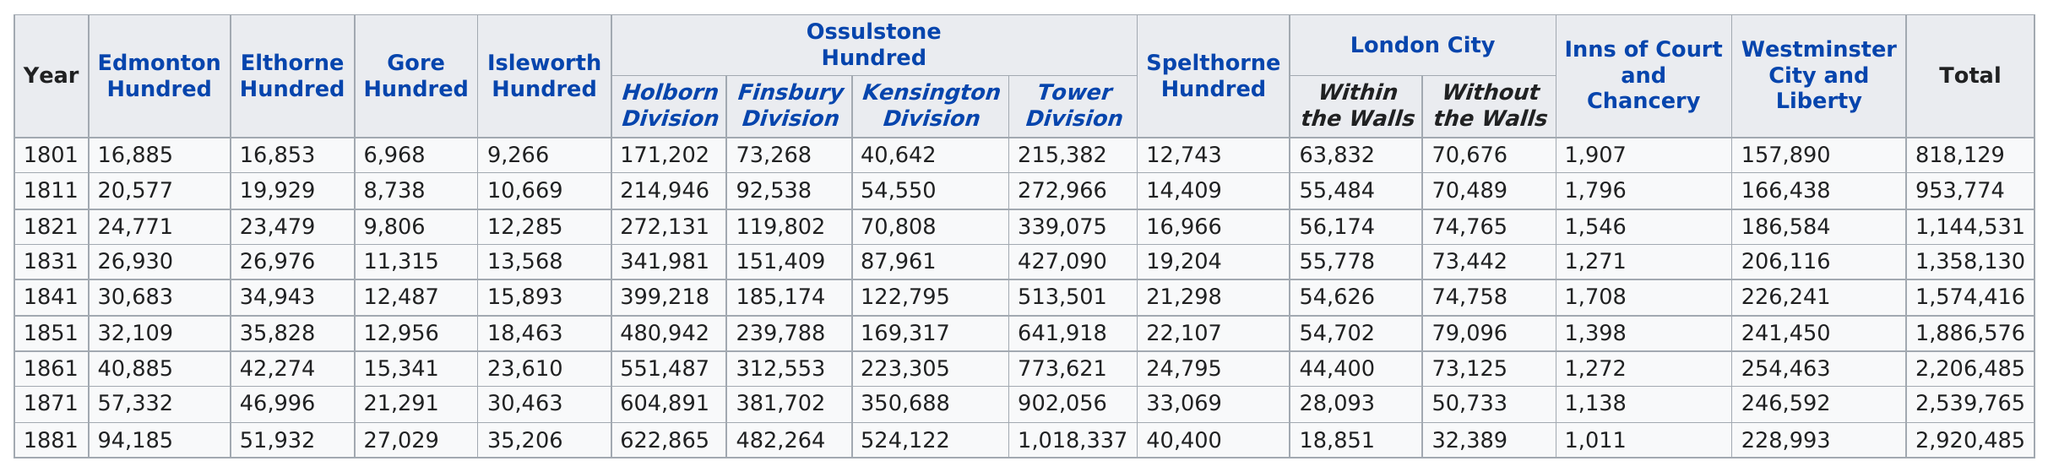Indicate a few pertinent items in this graphic. There is no evidence that Edmonton, Elthorne, or Gore Hundred had a higher aggregate population over time from 1801 to 1881 than any other Hundred. The available data on population size and population growth rate does not support such a conclusion. In 1831, the Elthorne Hundred and the Gore Hundred were distinct entities with different characteristics. In 1801, the Edmonton and Elthorne hundreds differed in their respective assessments of taxable property. In 1881, the most people lived in the Tower Division of Middlesex. In the year 1801, the total population was 818,129. 